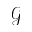<formula> <loc_0><loc_0><loc_500><loc_500>\mathcal { G }</formula> 